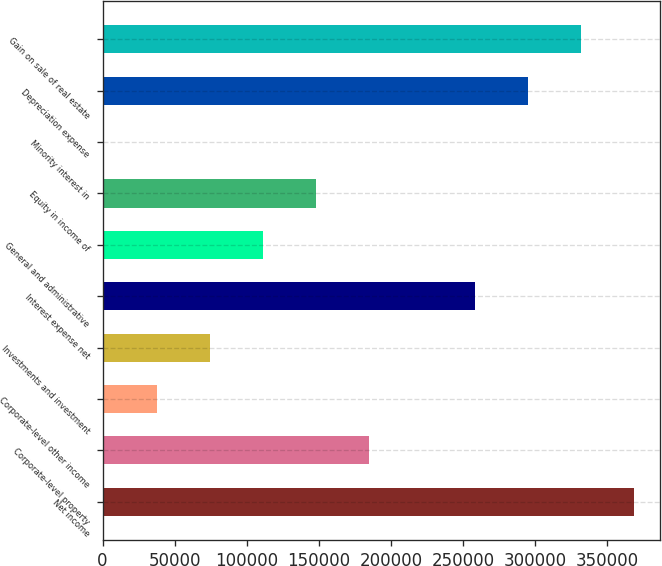Convert chart to OTSL. <chart><loc_0><loc_0><loc_500><loc_500><bar_chart><fcel>Net income<fcel>Corporate-level property<fcel>Corporate-level other income<fcel>Investments and investment<fcel>Interest expense net<fcel>General and administrative<fcel>Equity in income of<fcel>Minority interest in<fcel>Depreciation expense<fcel>Gain on sale of real estate<nl><fcel>368554<fcel>184752<fcel>37710.4<fcel>74470.8<fcel>258273<fcel>111231<fcel>147992<fcel>950<fcel>295033<fcel>331794<nl></chart> 